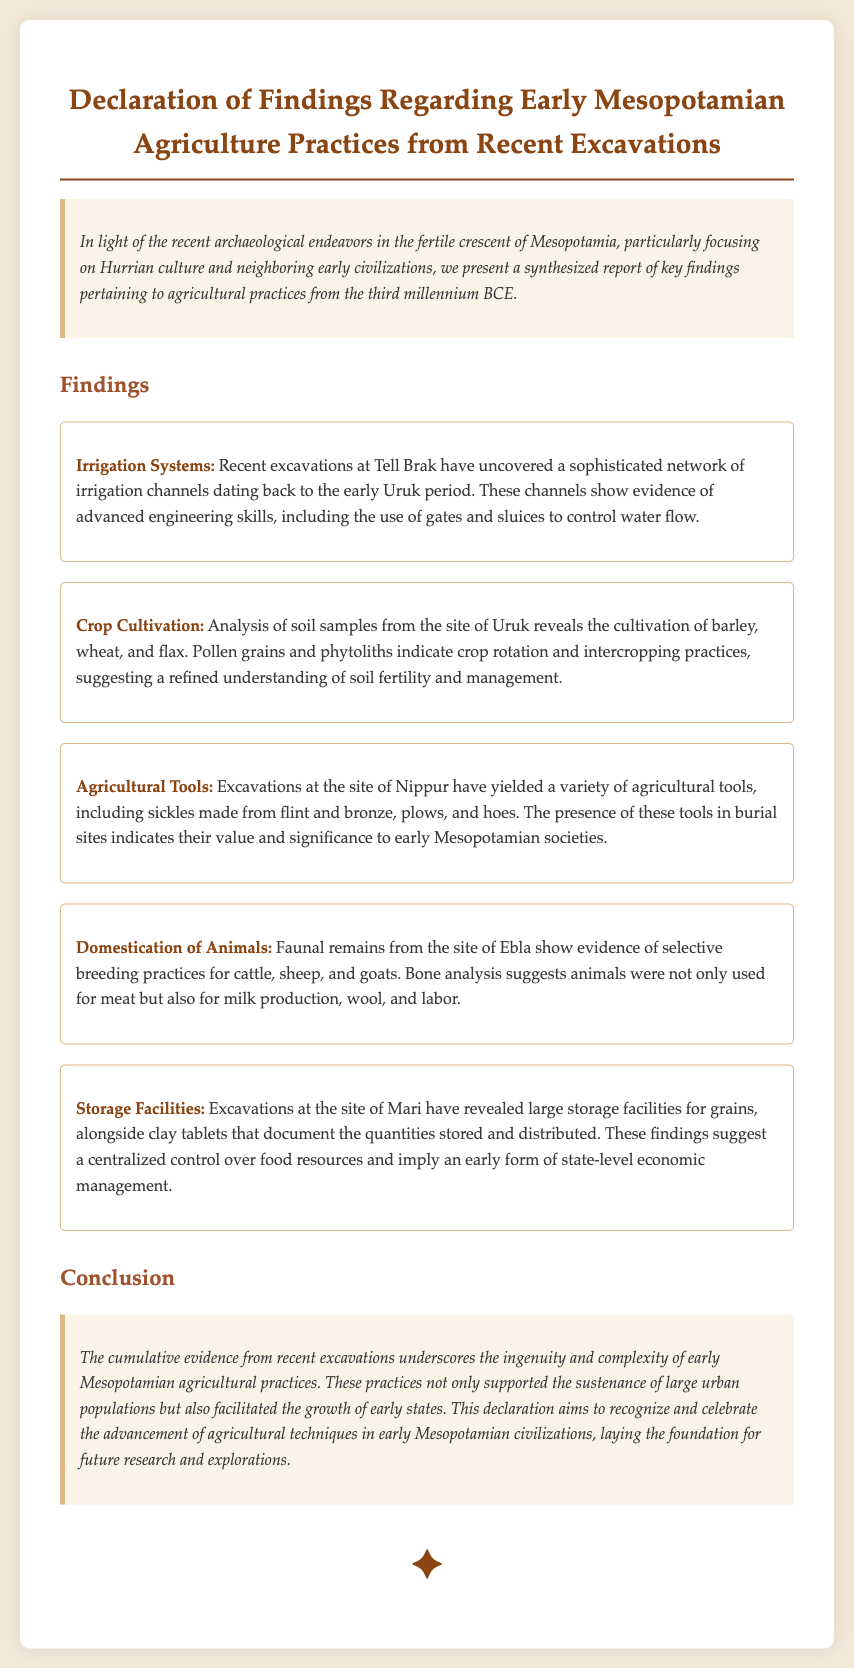What site showed evidence of advanced irrigation systems? The document states that recent excavations at Tell Brak have uncovered a sophisticated network of irrigation channels.
Answer: Tell Brak What crops were cultivated according to soil samples from Uruk? The findings indicate that barley, wheat, and flax were cultivated based on analyses of soil samples.
Answer: Barley, wheat, and flax What type of agricultural tools were found at Nippur? The document notes various tools, including sickles made from flint and bronze, plows, and hoes discovered at the site of Nippur.
Answer: Sickles, plows, and hoes What animal remains indicate selective breeding practices at Ebla? The findings highlight evidence of selective breeding for cattle, sheep, and goats through the analysis of faunal remains.
Answer: Cattle, sheep, and goats What do the storage facilities at Mari reveal about early economic management? The document suggests that the large storage facilities imply a centralized control over food resources, indicating early state-level economic management.
Answer: Centralized control over food resources What period do the agricultural findings date back to? The findings related to early agricultural practices are dated back to the third millennium BCE as noted in the introduction of the document.
Answer: Third millennium BCE What significance do the agricultural tools have in burial sites? The document implies that the presence of these tools in burial sites indicates their value and significance to early Mesopotamian societies.
Answer: Value and significance What is the overall conclusion regarding early Mesopotamian agricultural practices? The conclusion states that the evidence underscores the ingenuity and complexity of these practices, supporting urban populations and facilitating state growth.
Answer: Ingenuity and complexity 